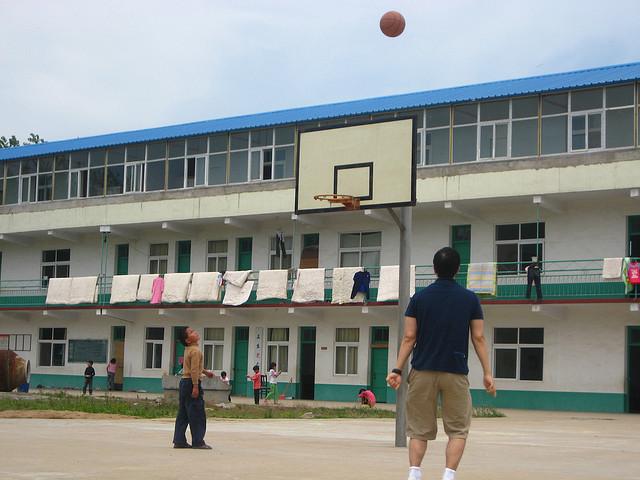Where are they gathered?
Keep it brief. Basketball court. What are these people doing?
Short answer required. Playing basketball. What game are the kids playing?
Be succinct. Basketball. What color is the net?
Concise answer only. White. Why are there sheets hanging on the balcony rails?
Short answer required. Drying. 